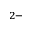<formula> <loc_0><loc_0><loc_500><loc_500>^ { 2 - }</formula> 